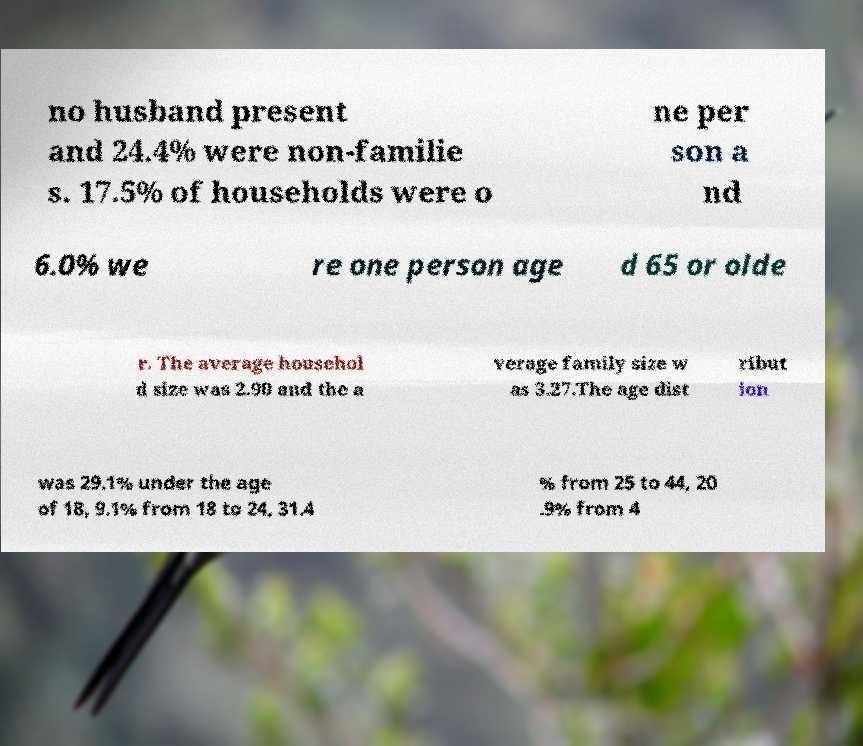Please read and relay the text visible in this image. What does it say? no husband present and 24.4% were non-familie s. 17.5% of households were o ne per son a nd 6.0% we re one person age d 65 or olde r. The average househol d size was 2.90 and the a verage family size w as 3.27.The age dist ribut ion was 29.1% under the age of 18, 9.1% from 18 to 24, 31.4 % from 25 to 44, 20 .9% from 4 